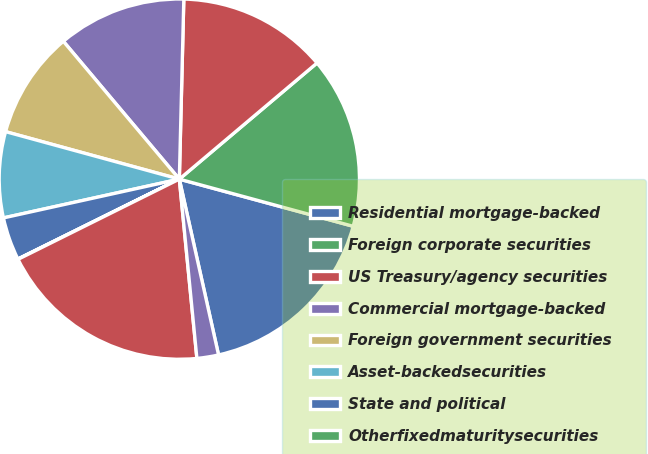Convert chart to OTSL. <chart><loc_0><loc_0><loc_500><loc_500><pie_chart><fcel>Residential mortgage-backed<fcel>Foreign corporate securities<fcel>US Treasury/agency securities<fcel>Commercial mortgage-backed<fcel>Foreign government securities<fcel>Asset-backedsecurities<fcel>State and political<fcel>Otherfixedmaturitysecurities<fcel>Total fixed maturity<fcel>Non-redeemablepreferredstock<nl><fcel>17.29%<fcel>15.37%<fcel>13.45%<fcel>11.53%<fcel>9.62%<fcel>7.7%<fcel>3.86%<fcel>0.03%<fcel>19.21%<fcel>1.94%<nl></chart> 